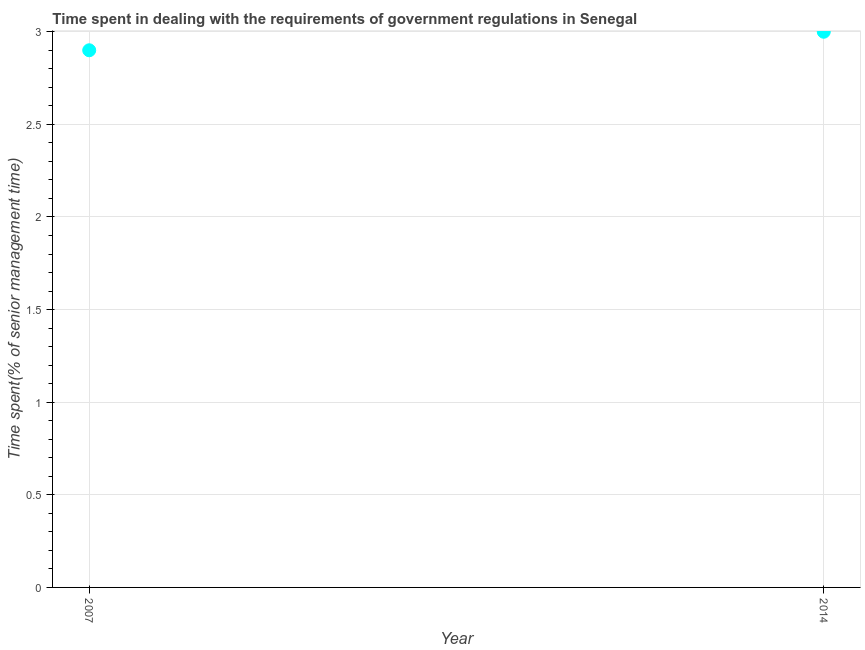Across all years, what is the minimum time spent in dealing with government regulations?
Your response must be concise. 2.9. In which year was the time spent in dealing with government regulations maximum?
Keep it short and to the point. 2014. In which year was the time spent in dealing with government regulations minimum?
Provide a succinct answer. 2007. What is the difference between the time spent in dealing with government regulations in 2007 and 2014?
Your answer should be very brief. -0.1. What is the average time spent in dealing with government regulations per year?
Your answer should be compact. 2.95. What is the median time spent in dealing with government regulations?
Ensure brevity in your answer.  2.95. In how many years, is the time spent in dealing with government regulations greater than 2.9 %?
Ensure brevity in your answer.  1. Do a majority of the years between 2007 and 2014 (inclusive) have time spent in dealing with government regulations greater than 0.30000000000000004 %?
Ensure brevity in your answer.  Yes. What is the ratio of the time spent in dealing with government regulations in 2007 to that in 2014?
Give a very brief answer. 0.97. Does the time spent in dealing with government regulations monotonically increase over the years?
Provide a succinct answer. Yes. How many dotlines are there?
Your response must be concise. 1. How many years are there in the graph?
Give a very brief answer. 2. What is the title of the graph?
Keep it short and to the point. Time spent in dealing with the requirements of government regulations in Senegal. What is the label or title of the Y-axis?
Offer a very short reply. Time spent(% of senior management time). What is the Time spent(% of senior management time) in 2014?
Provide a succinct answer. 3. What is the ratio of the Time spent(% of senior management time) in 2007 to that in 2014?
Give a very brief answer. 0.97. 